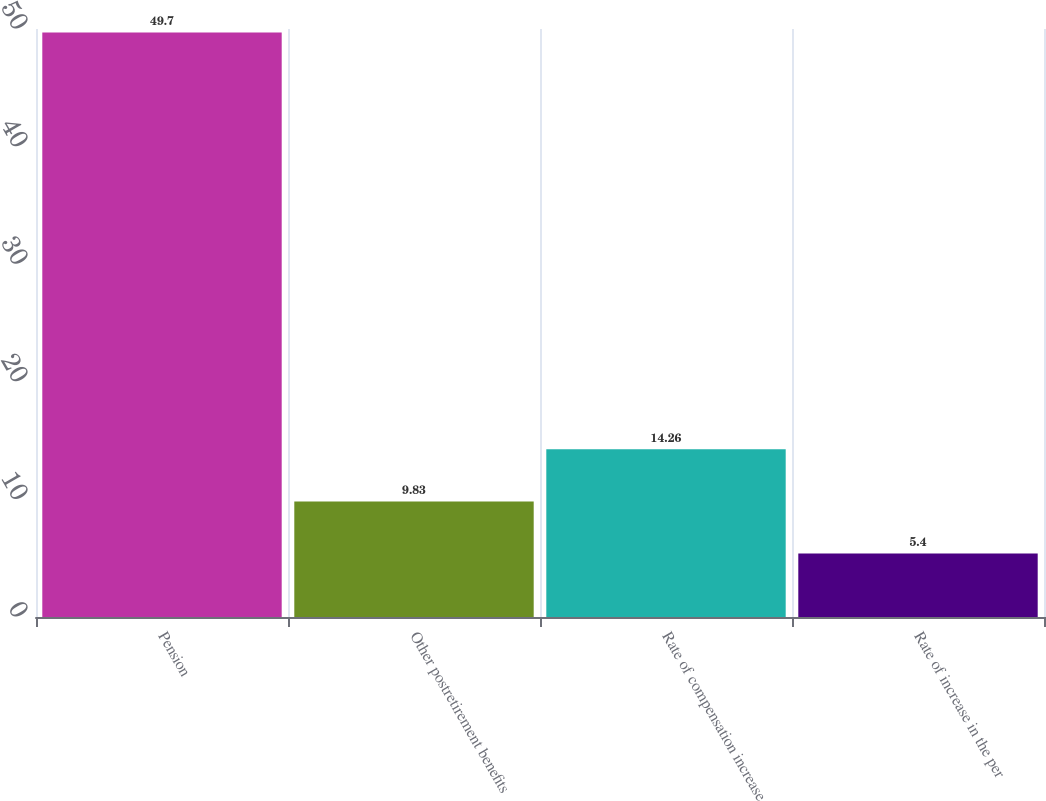Convert chart. <chart><loc_0><loc_0><loc_500><loc_500><bar_chart><fcel>Pension<fcel>Other postretirement benefits<fcel>Rate of compensation increase<fcel>Rate of increase in the per<nl><fcel>49.7<fcel>9.83<fcel>14.26<fcel>5.4<nl></chart> 